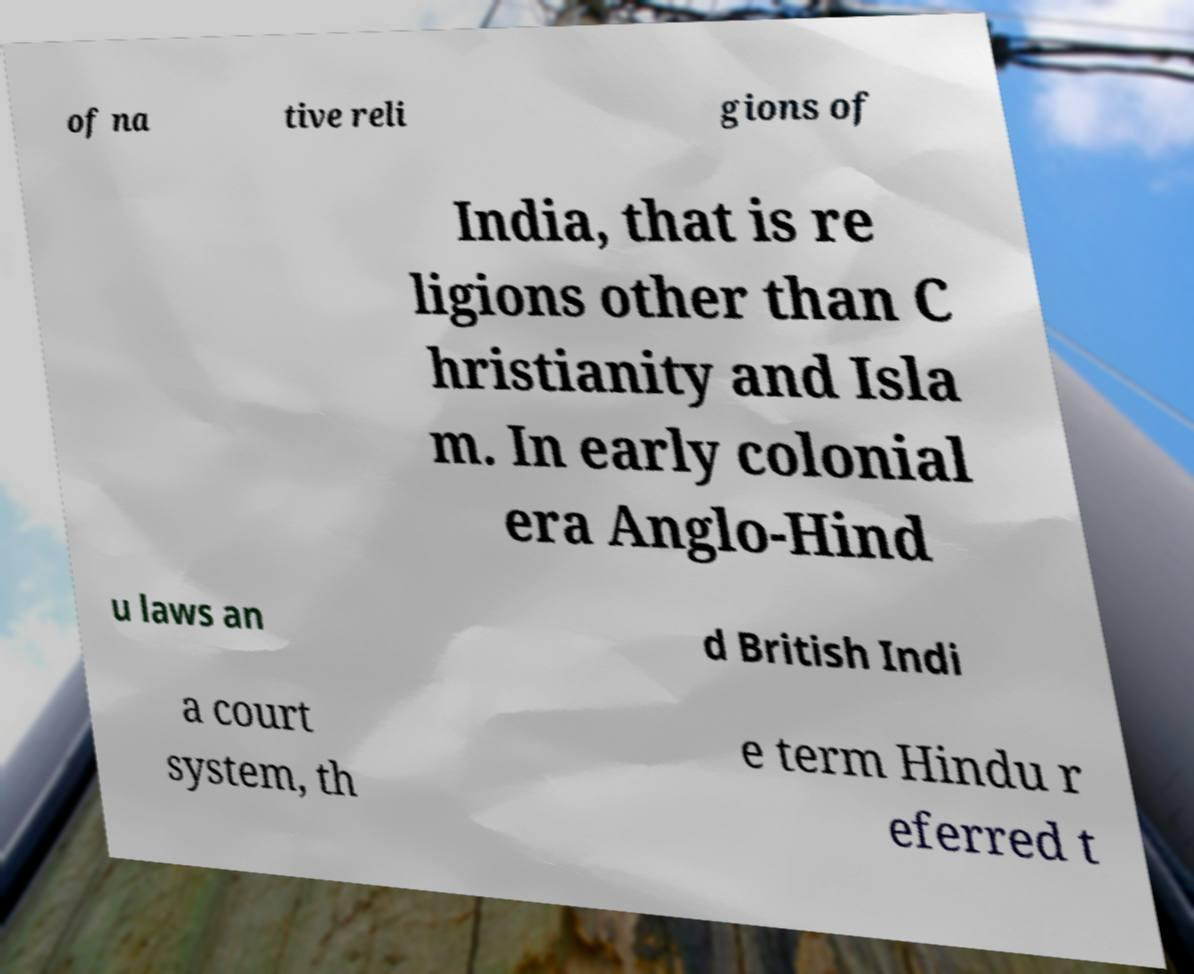Please identify and transcribe the text found in this image. of na tive reli gions of India, that is re ligions other than C hristianity and Isla m. In early colonial era Anglo-Hind u laws an d British Indi a court system, th e term Hindu r eferred t 